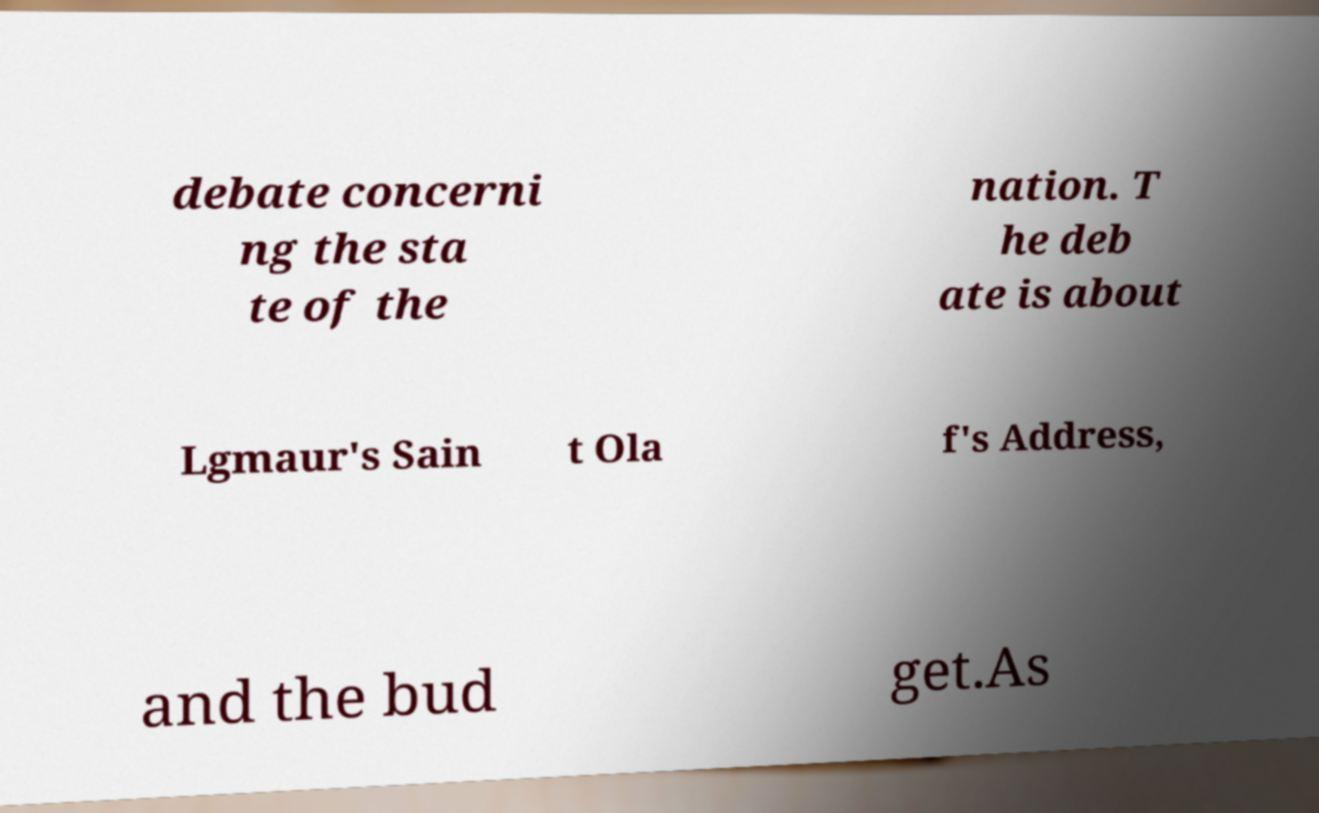What messages or text are displayed in this image? I need them in a readable, typed format. debate concerni ng the sta te of the nation. T he deb ate is about Lgmaur's Sain t Ola f's Address, and the bud get.As 